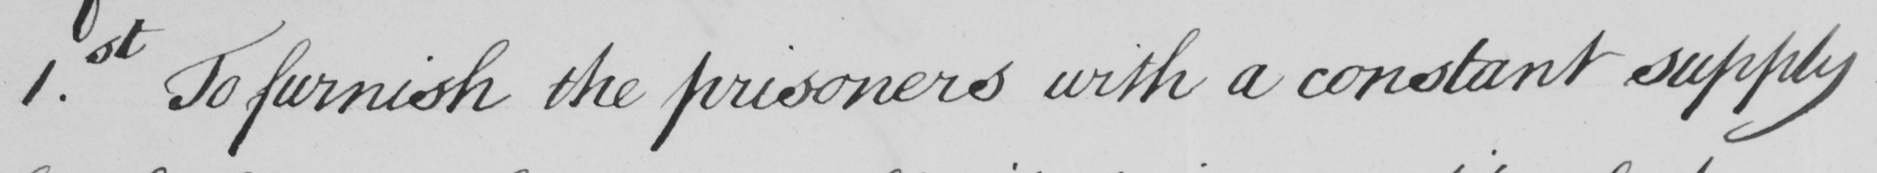What does this handwritten line say? 1.st To furnish the prisoners with a constant supply 